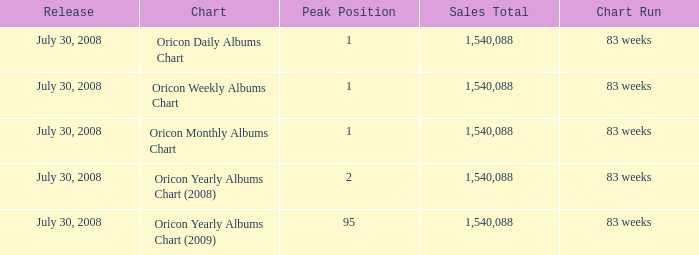What is the sales total represented in the oricon monthly albums chart? 1540088.0. 